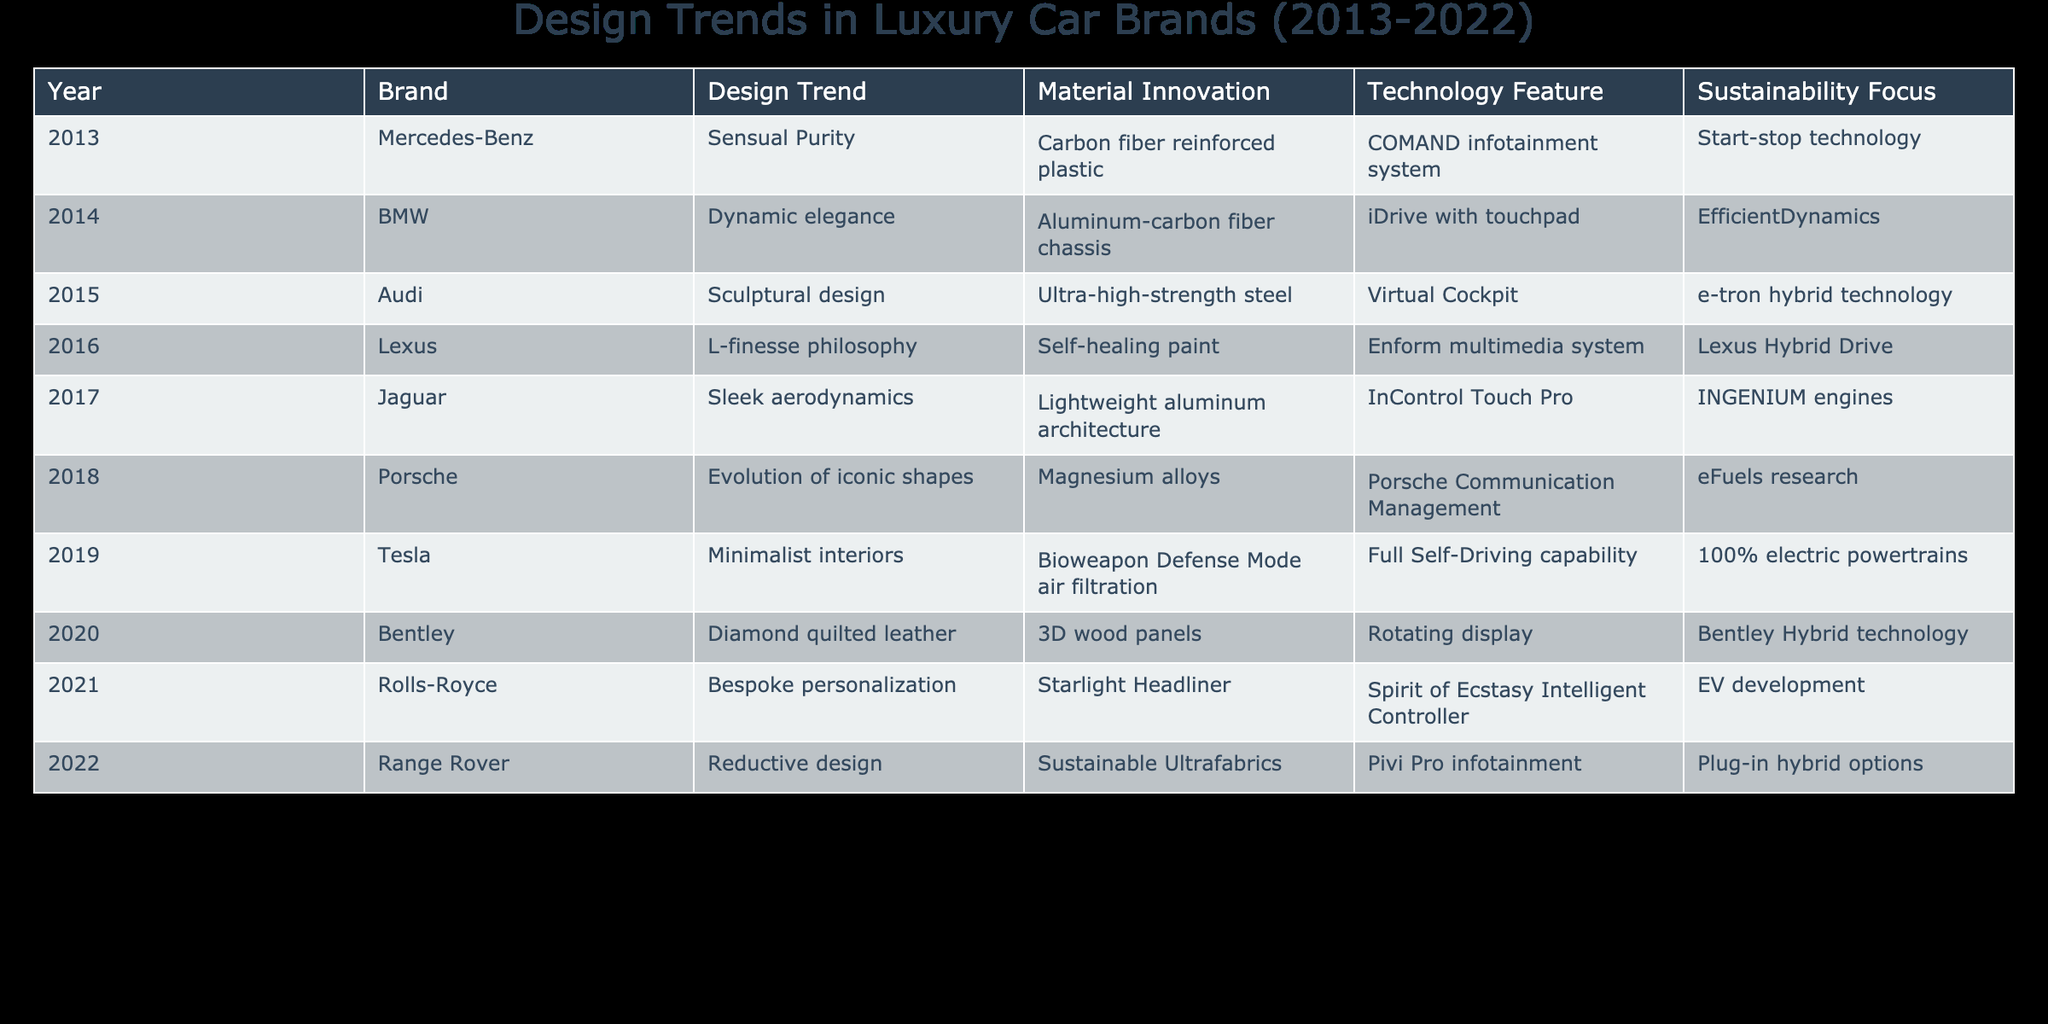What design trend did Tesla adopt in 2019? In 2019, Tesla adopted the design trend of minimalist interiors, which focuses on simplicity and clean lines. This can be found in the row corresponding to Tesla in the table.
Answer: Minimalist interiors Which brand introduced a self-healing paint technology in 2016? The table indicates that Lexus introduced a self-healing paint technology in 2016, as referenced in the respective row for that year and brand.
Answer: Lexus Was the focus on sustainability consistent across all luxury car brands over the decade? No, not all brands consistently focused on sustainability; for example, brands like Audi and Jaguar did not highlight sustainability in the table, while Tesla and Range Rover emphasized it in their entries.
Answer: No Which brand had the latest design trend focusing on reductive design, and what year was it introduced? The most recent brand focusing on reductive design is Range Rover, which introduced this design trend in 2022, as listed in the corresponding row of the table.
Answer: Range Rover, 2022 What is the average number of sustainability features mentioned in the table for the years listed? To find the average, we count the sustainability features: 9 features total over 10 years. The average is 9/10 = 0.9 features per year.
Answer: 0.9 features per year Did Bentley incorporate any innovative materials in 2020? Yes, Bentley introduced 3D wood panels as a material innovation in 2020, as shown in the relevant row of the table.
Answer: Yes Which years show a technological feature focused on hybrid technology? The years 2015 (e-tron hybrid technology), 2016 (Lexus Hybrid Drive), 2020 (Bentley Hybrid technology), and 2022 (Plug-in hybrid options) all show a focus on hybrid technology across different brands as gathered from their respective entries.
Answer: 2015, 2016, 2020, 2022 Which brand exhibited the most innovative material technology in 2018? Porsche was the brand in 2018 that introduced magnesium alloys, which is represented as an innovative material in that year's row of the table.
Answer: Porsche How many distinct design trends were noted in the table during the last decade? There are 10 distinct design trends mentioned across the years from 2013 to 2022: Sensual Purity, Dynamic elegance, Sculptural design, L-finesse philosophy, Sleek aerodynamics, Evolution of iconic shapes, Minimalist interiors, Diamond quilted leather, Bespoke personalization, and Reductive design. This gives us a total of 10 distinct trends.
Answer: 10 distinct trends 